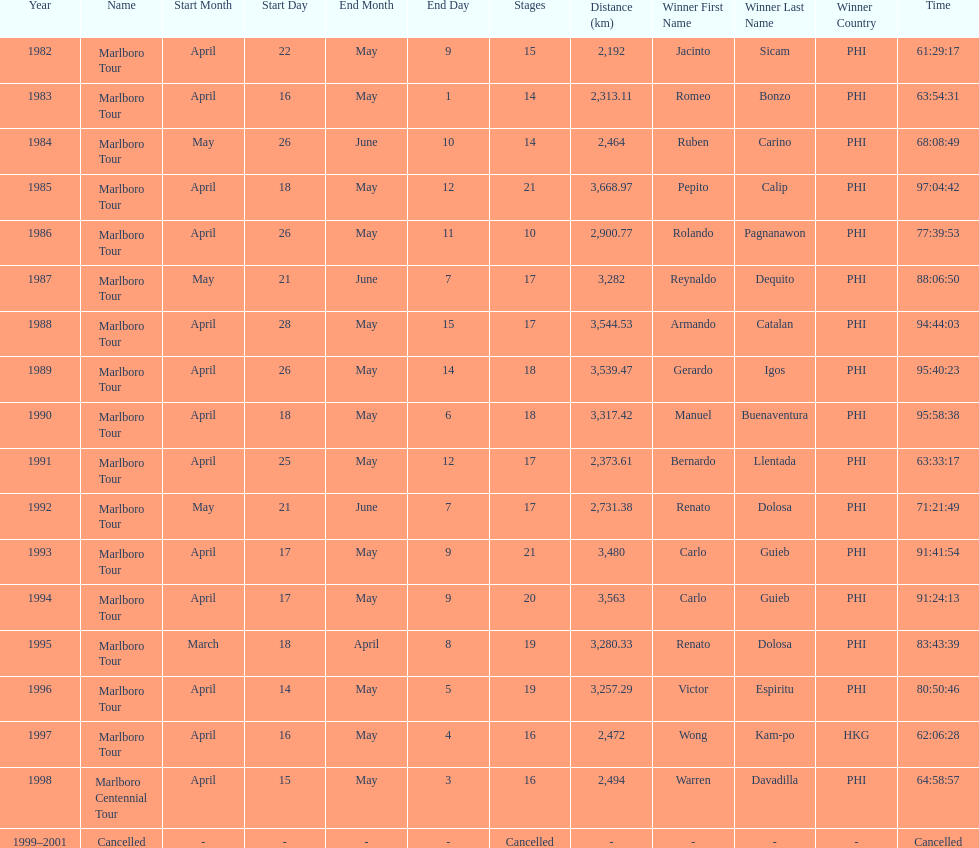Who is listed before wong kam-po? Victor Espiritu (PHI). 